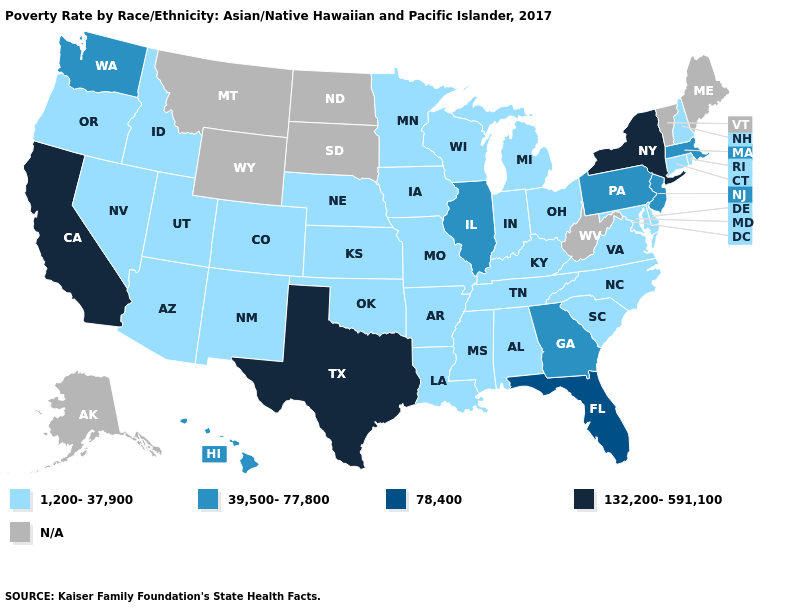Among the states that border Tennessee , does Kentucky have the highest value?
Keep it brief. No. Which states have the lowest value in the USA?
Answer briefly. Alabama, Arizona, Arkansas, Colorado, Connecticut, Delaware, Idaho, Indiana, Iowa, Kansas, Kentucky, Louisiana, Maryland, Michigan, Minnesota, Mississippi, Missouri, Nebraska, Nevada, New Hampshire, New Mexico, North Carolina, Ohio, Oklahoma, Oregon, Rhode Island, South Carolina, Tennessee, Utah, Virginia, Wisconsin. Among the states that border Wisconsin , does Minnesota have the lowest value?
Write a very short answer. Yes. Name the states that have a value in the range 1,200-37,900?
Write a very short answer. Alabama, Arizona, Arkansas, Colorado, Connecticut, Delaware, Idaho, Indiana, Iowa, Kansas, Kentucky, Louisiana, Maryland, Michigan, Minnesota, Mississippi, Missouri, Nebraska, Nevada, New Hampshire, New Mexico, North Carolina, Ohio, Oklahoma, Oregon, Rhode Island, South Carolina, Tennessee, Utah, Virginia, Wisconsin. Name the states that have a value in the range 132,200-591,100?
Be succinct. California, New York, Texas. Is the legend a continuous bar?
Short answer required. No. What is the highest value in the USA?
Write a very short answer. 132,200-591,100. Among the states that border Michigan , which have the lowest value?
Write a very short answer. Indiana, Ohio, Wisconsin. Name the states that have a value in the range N/A?
Be succinct. Alaska, Maine, Montana, North Dakota, South Dakota, Vermont, West Virginia, Wyoming. Among the states that border Arkansas , which have the lowest value?
Answer briefly. Louisiana, Mississippi, Missouri, Oklahoma, Tennessee. How many symbols are there in the legend?
Quick response, please. 5. Which states have the highest value in the USA?
Answer briefly. California, New York, Texas. How many symbols are there in the legend?
Give a very brief answer. 5. 